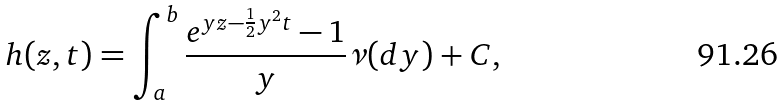<formula> <loc_0><loc_0><loc_500><loc_500>h ( z , t ) = \int _ { a } ^ { b } \frac { e ^ { y z - \frac { 1 } { 2 } y ^ { 2 } t } - 1 } { y } \nu ( d y ) + C ,</formula> 